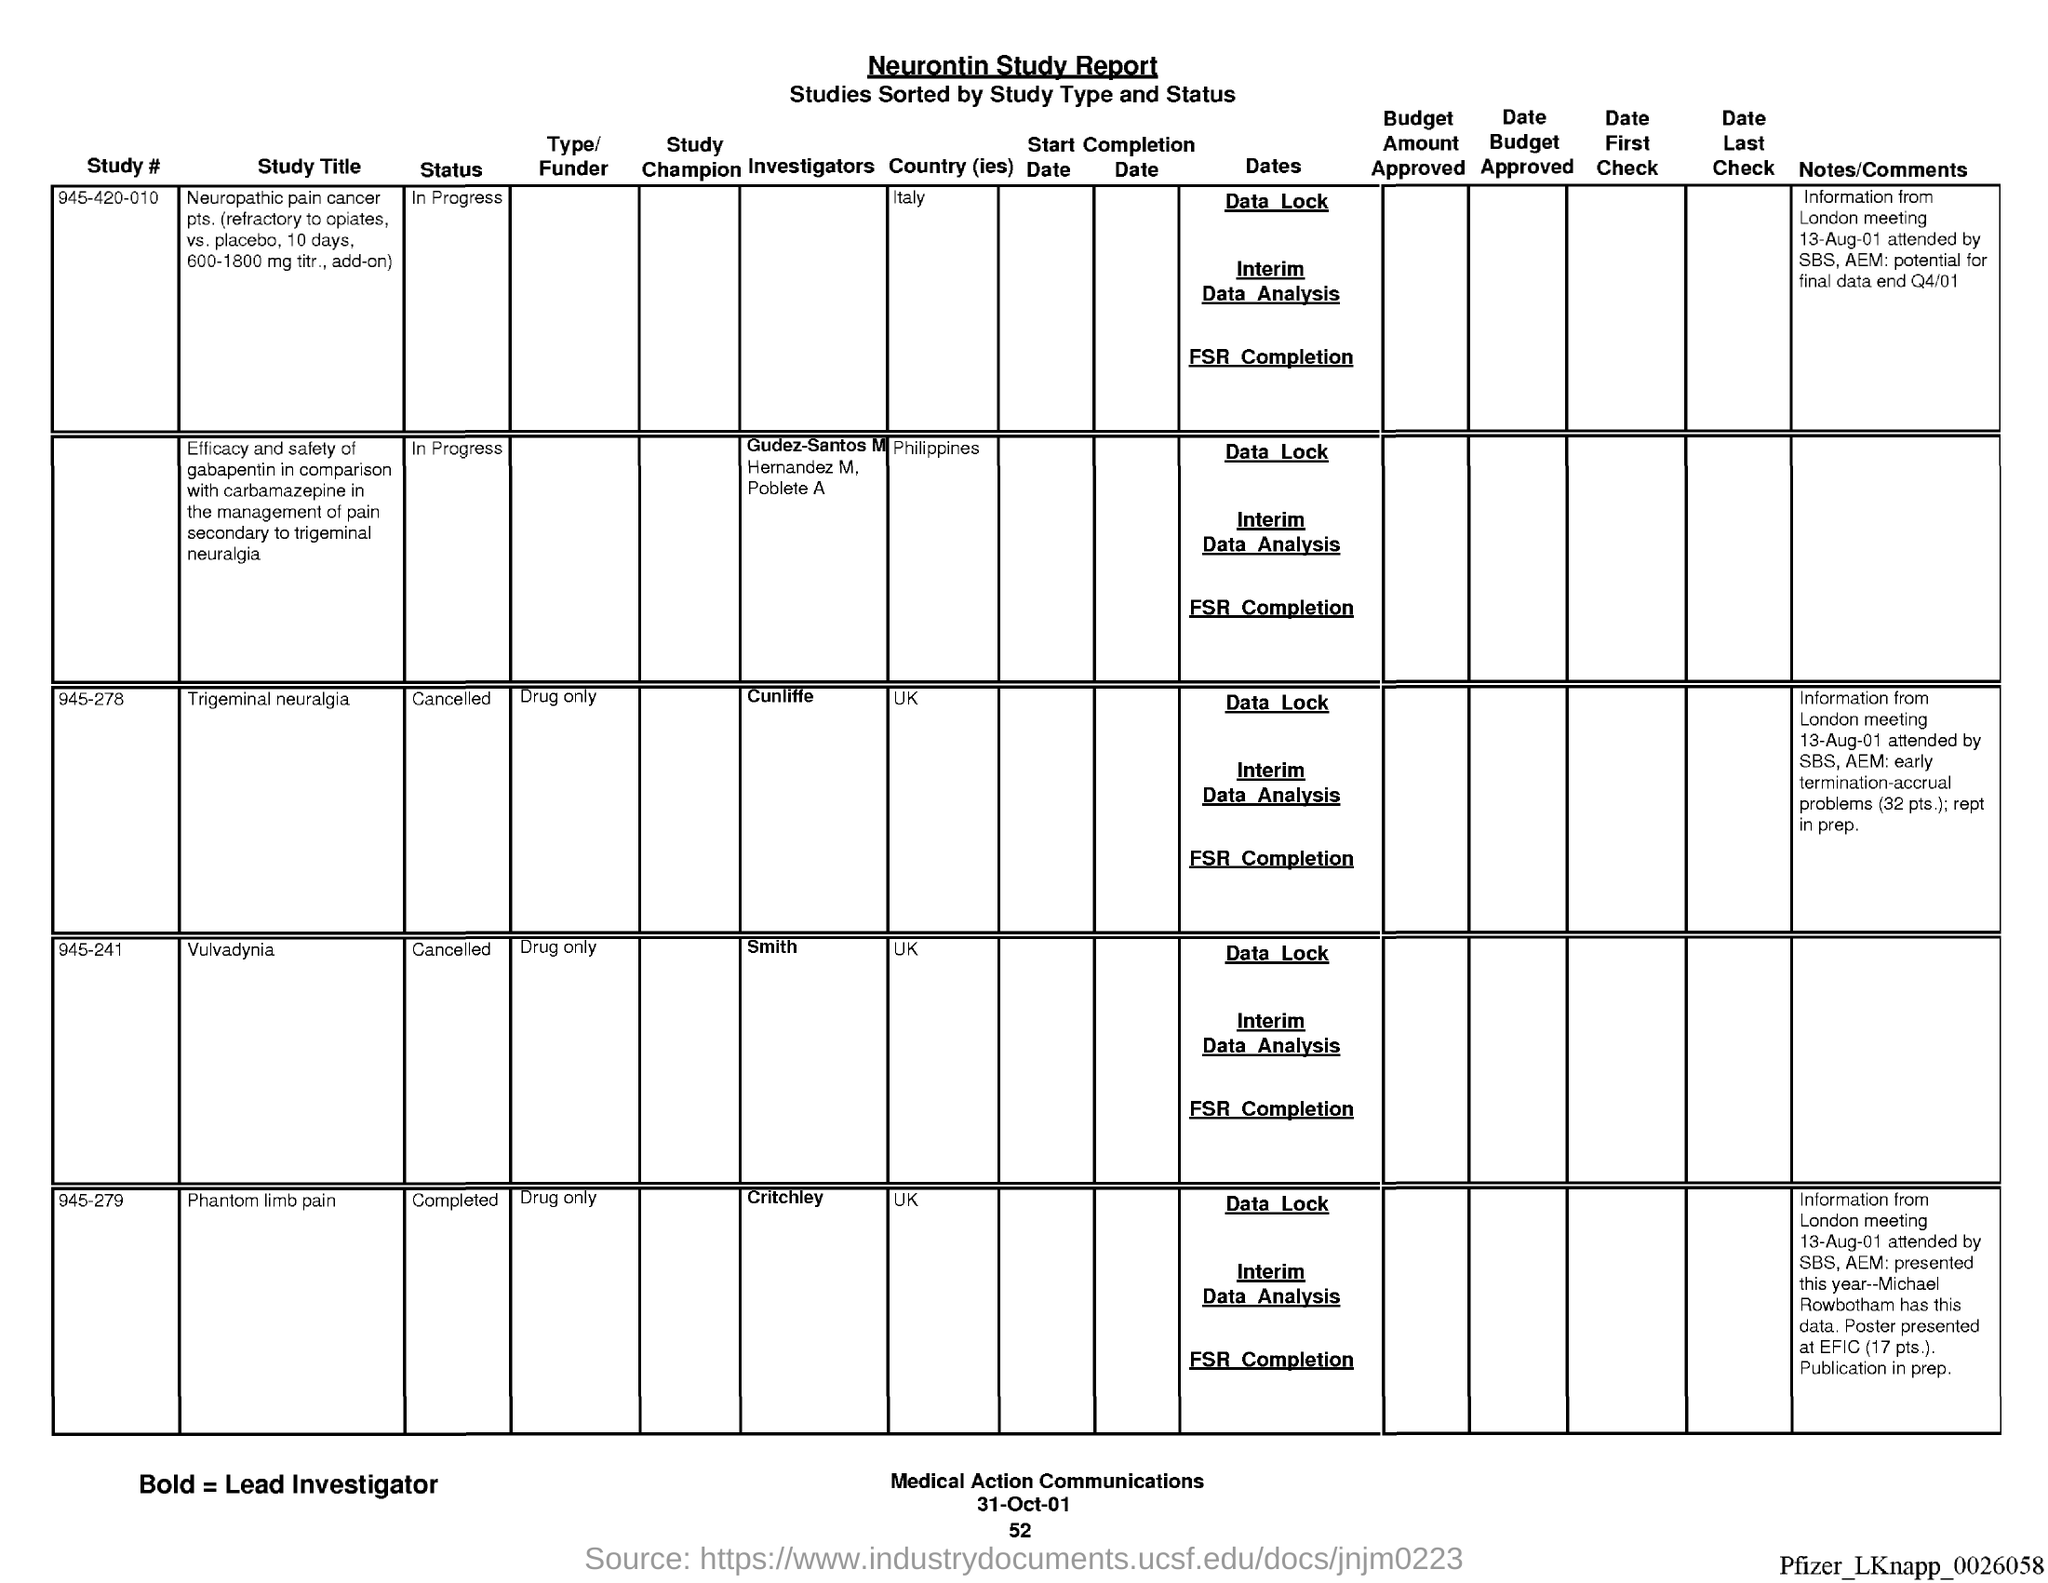Outline some significant characteristics in this image. The status of study # 945-420-010 is currently "in progress. The date mentioned at the bottom of the document is October 31, 2001. The study number 945-278 is funded by a drug-only funder. The type of study is not specified. Study #945-278 mentions the United Kingdom as the country of study. The London meeting was held on August 13, 2001. 